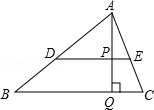Clarify your interpretation of the image. The image presents a geometric diagram including triangle ABC, where points B and C lie on the horizontal base. Line DE is parallel to line BC. From vertex A, a perpendicular line AQ intersects BC at Q and continues to intersect line DE at point P. Additionally, line AD connects point A and D, possibly suggesting further geometric relationships or constructions such as similar triangles or application of the midpoint theorem. 